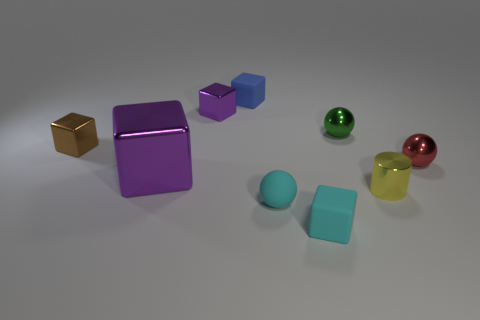What is the color of the cube on the right side of the rubber block behind the sphere in front of the large metallic thing?
Ensure brevity in your answer.  Cyan. Is the number of yellow shiny blocks less than the number of small purple objects?
Give a very brief answer. Yes. What is the color of the other metallic thing that is the same shape as the red metallic object?
Keep it short and to the point. Green. There is a big block that is made of the same material as the yellow object; what color is it?
Offer a terse response. Purple. How many purple balls are the same size as the green metal sphere?
Provide a succinct answer. 0. What material is the red sphere?
Make the answer very short. Metal. Is the number of tiny metallic balls greater than the number of big brown matte blocks?
Your answer should be very brief. Yes. Is the big purple thing the same shape as the yellow object?
Give a very brief answer. No. Is there any other thing that is the same shape as the green metal object?
Provide a succinct answer. Yes. Do the matte block to the left of the cyan rubber cube and the tiny shiny thing that is behind the green thing have the same color?
Your answer should be compact. No. 